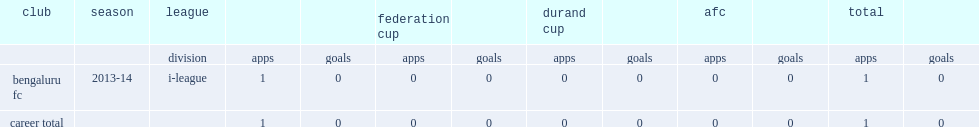Which league did amoes join bengaluru fc for the 2013-14? I-league. 